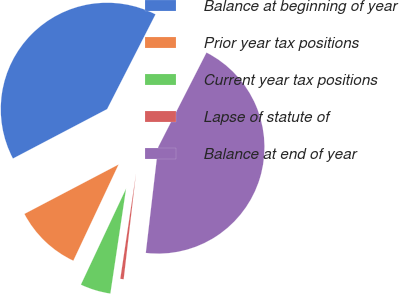<chart> <loc_0><loc_0><loc_500><loc_500><pie_chart><fcel>Balance at beginning of year<fcel>Prior year tax positions<fcel>Current year tax positions<fcel>Lapse of statute of<fcel>Balance at end of year<nl><fcel>40.21%<fcel>10.31%<fcel>4.63%<fcel>0.52%<fcel>44.33%<nl></chart> 